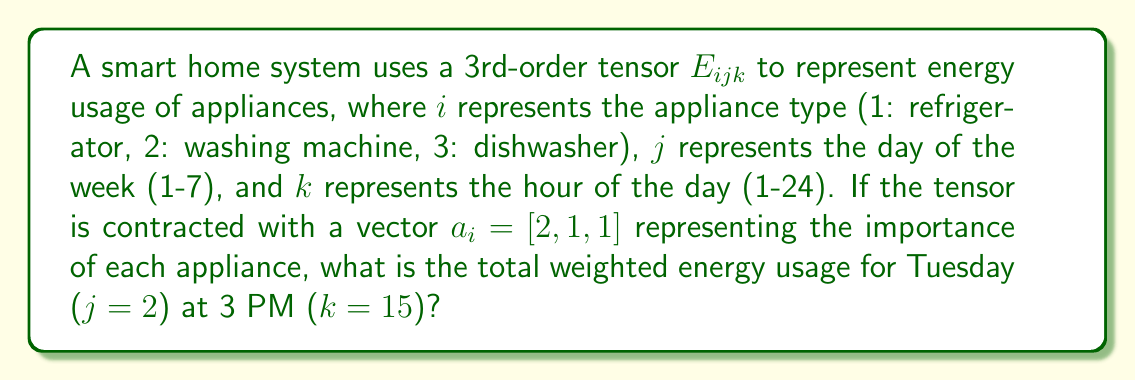Give your solution to this math problem. Let's approach this step-by-step:

1) The tensor contraction we need to perform is:

   $$R_{jk} = a_i E_{ijk}$$

2) This contraction sums over the $i$ index, giving us a 2nd-order tensor (matrix) $R_{jk}$ that represents the weighted energy usage for each day and hour.

3) We're specifically interested in Tuesday (j=2) at 3 PM (k=15), so we need to calculate:

   $$R_{2,15} = a_1 E_{1,2,15} + a_2 E_{2,2,15} + a_3 E_{3,2,15}$$

4) Substituting the values for $a_i$:

   $$R_{2,15} = 2E_{1,2,15} + 1E_{2,2,15} + 1E_{3,2,15}$$

5) Let's assume the following energy usage values (in kWh) for this specific time:
   - Refrigerator (i=1): $E_{1,2,15} = 0.5$
   - Washing Machine (i=2): $E_{2,2,15} = 2.0$
   - Dishwasher (i=3): $E_{3,2,15} = 1.5$

6) Now we can calculate:

   $$R_{2,15} = 2(0.5) + 1(2.0) + 1(1.5) = 1 + 2 + 1.5 = 4.5$$

Therefore, the total weighted energy usage for Tuesday at 3 PM is 4.5 kWh.
Answer: 4.5 kWh 